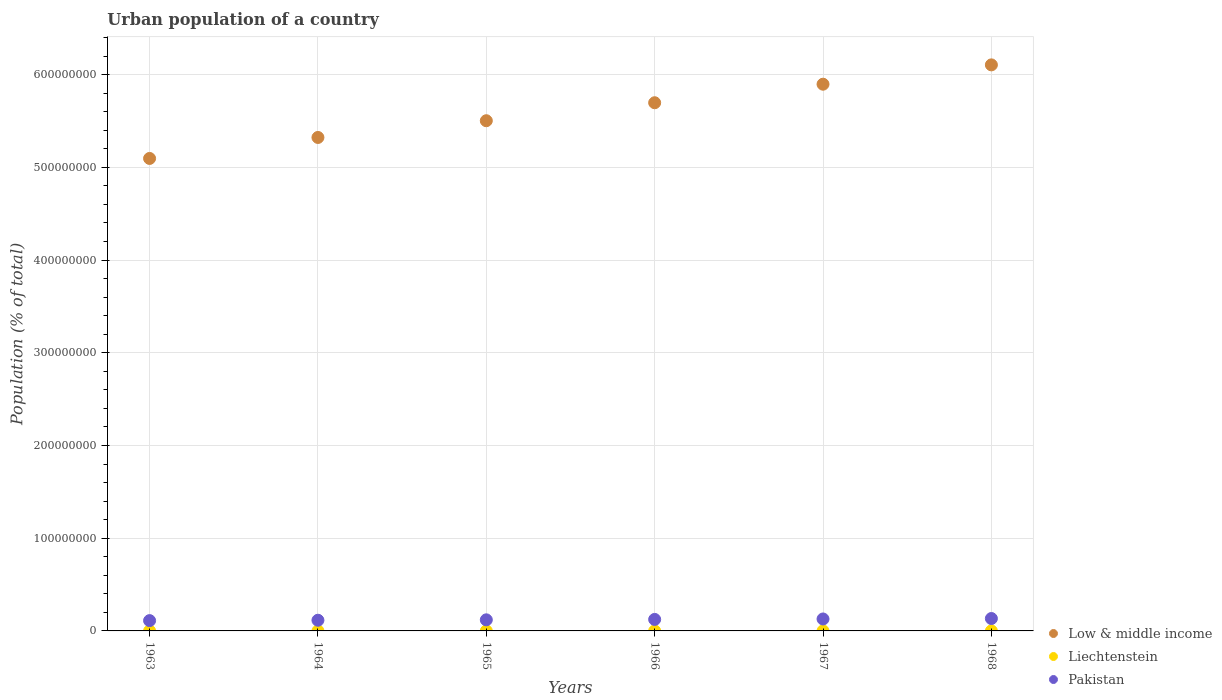How many different coloured dotlines are there?
Provide a succinct answer. 3. Is the number of dotlines equal to the number of legend labels?
Offer a very short reply. Yes. What is the urban population in Low & middle income in 1966?
Make the answer very short. 5.70e+08. Across all years, what is the maximum urban population in Low & middle income?
Offer a very short reply. 6.10e+08. Across all years, what is the minimum urban population in Low & middle income?
Keep it short and to the point. 5.10e+08. In which year was the urban population in Liechtenstein maximum?
Your answer should be very brief. 1968. What is the total urban population in Liechtenstein in the graph?
Offer a terse response. 2.20e+04. What is the difference between the urban population in Pakistan in 1965 and that in 1966?
Ensure brevity in your answer.  -4.51e+05. What is the difference between the urban population in Pakistan in 1968 and the urban population in Low & middle income in 1964?
Give a very brief answer. -5.19e+08. What is the average urban population in Pakistan per year?
Your answer should be compact. 1.22e+07. In the year 1968, what is the difference between the urban population in Liechtenstein and urban population in Pakistan?
Provide a succinct answer. -1.34e+07. What is the ratio of the urban population in Pakistan in 1967 to that in 1968?
Your answer should be very brief. 0.96. Is the urban population in Low & middle income in 1963 less than that in 1965?
Keep it short and to the point. Yes. What is the difference between the highest and the lowest urban population in Pakistan?
Your answer should be very brief. 2.26e+06. In how many years, is the urban population in Liechtenstein greater than the average urban population in Liechtenstein taken over all years?
Keep it short and to the point. 3. Is the sum of the urban population in Low & middle income in 1963 and 1966 greater than the maximum urban population in Pakistan across all years?
Offer a terse response. Yes. Is it the case that in every year, the sum of the urban population in Pakistan and urban population in Liechtenstein  is greater than the urban population in Low & middle income?
Give a very brief answer. No. Is the urban population in Liechtenstein strictly greater than the urban population in Low & middle income over the years?
Your answer should be very brief. No. Is the urban population in Liechtenstein strictly less than the urban population in Low & middle income over the years?
Make the answer very short. Yes. How many dotlines are there?
Make the answer very short. 3. How many years are there in the graph?
Your answer should be very brief. 6. Does the graph contain grids?
Make the answer very short. Yes. What is the title of the graph?
Make the answer very short. Urban population of a country. What is the label or title of the Y-axis?
Give a very brief answer. Population (% of total). What is the Population (% of total) of Low & middle income in 1963?
Ensure brevity in your answer.  5.10e+08. What is the Population (% of total) of Liechtenstein in 1963?
Offer a very short reply. 3525. What is the Population (% of total) in Pakistan in 1963?
Your answer should be compact. 1.11e+07. What is the Population (% of total) of Low & middle income in 1964?
Make the answer very short. 5.32e+08. What is the Population (% of total) of Liechtenstein in 1964?
Your answer should be compact. 3576. What is the Population (% of total) of Pakistan in 1964?
Your response must be concise. 1.15e+07. What is the Population (% of total) in Low & middle income in 1965?
Provide a short and direct response. 5.50e+08. What is the Population (% of total) of Liechtenstein in 1965?
Provide a succinct answer. 3631. What is the Population (% of total) in Pakistan in 1965?
Provide a short and direct response. 1.20e+07. What is the Population (% of total) in Low & middle income in 1966?
Give a very brief answer. 5.70e+08. What is the Population (% of total) in Liechtenstein in 1966?
Your response must be concise. 3690. What is the Population (% of total) in Pakistan in 1966?
Offer a terse response. 1.24e+07. What is the Population (% of total) of Low & middle income in 1967?
Offer a terse response. 5.90e+08. What is the Population (% of total) in Liechtenstein in 1967?
Your response must be concise. 3753. What is the Population (% of total) of Pakistan in 1967?
Provide a succinct answer. 1.29e+07. What is the Population (% of total) in Low & middle income in 1968?
Offer a very short reply. 6.10e+08. What is the Population (% of total) in Liechtenstein in 1968?
Your response must be concise. 3815. What is the Population (% of total) in Pakistan in 1968?
Offer a very short reply. 1.34e+07. Across all years, what is the maximum Population (% of total) of Low & middle income?
Keep it short and to the point. 6.10e+08. Across all years, what is the maximum Population (% of total) in Liechtenstein?
Offer a terse response. 3815. Across all years, what is the maximum Population (% of total) in Pakistan?
Give a very brief answer. 1.34e+07. Across all years, what is the minimum Population (% of total) of Low & middle income?
Provide a succinct answer. 5.10e+08. Across all years, what is the minimum Population (% of total) of Liechtenstein?
Keep it short and to the point. 3525. Across all years, what is the minimum Population (% of total) in Pakistan?
Make the answer very short. 1.11e+07. What is the total Population (% of total) in Low & middle income in the graph?
Your answer should be compact. 3.36e+09. What is the total Population (% of total) of Liechtenstein in the graph?
Ensure brevity in your answer.  2.20e+04. What is the total Population (% of total) of Pakistan in the graph?
Your answer should be very brief. 7.32e+07. What is the difference between the Population (% of total) in Low & middle income in 1963 and that in 1964?
Your answer should be very brief. -2.26e+07. What is the difference between the Population (% of total) of Liechtenstein in 1963 and that in 1964?
Provide a succinct answer. -51. What is the difference between the Population (% of total) in Pakistan in 1963 and that in 1964?
Give a very brief answer. -4.12e+05. What is the difference between the Population (% of total) in Low & middle income in 1963 and that in 1965?
Provide a short and direct response. -4.07e+07. What is the difference between the Population (% of total) in Liechtenstein in 1963 and that in 1965?
Make the answer very short. -106. What is the difference between the Population (% of total) in Pakistan in 1963 and that in 1965?
Provide a short and direct response. -8.42e+05. What is the difference between the Population (% of total) of Low & middle income in 1963 and that in 1966?
Provide a short and direct response. -6.01e+07. What is the difference between the Population (% of total) in Liechtenstein in 1963 and that in 1966?
Your response must be concise. -165. What is the difference between the Population (% of total) in Pakistan in 1963 and that in 1966?
Your response must be concise. -1.29e+06. What is the difference between the Population (% of total) of Low & middle income in 1963 and that in 1967?
Give a very brief answer. -8.01e+07. What is the difference between the Population (% of total) in Liechtenstein in 1963 and that in 1967?
Offer a very short reply. -228. What is the difference between the Population (% of total) of Pakistan in 1963 and that in 1967?
Ensure brevity in your answer.  -1.76e+06. What is the difference between the Population (% of total) of Low & middle income in 1963 and that in 1968?
Offer a terse response. -1.01e+08. What is the difference between the Population (% of total) in Liechtenstein in 1963 and that in 1968?
Your answer should be compact. -290. What is the difference between the Population (% of total) in Pakistan in 1963 and that in 1968?
Your response must be concise. -2.26e+06. What is the difference between the Population (% of total) in Low & middle income in 1964 and that in 1965?
Provide a succinct answer. -1.80e+07. What is the difference between the Population (% of total) of Liechtenstein in 1964 and that in 1965?
Your response must be concise. -55. What is the difference between the Population (% of total) in Pakistan in 1964 and that in 1965?
Offer a terse response. -4.30e+05. What is the difference between the Population (% of total) of Low & middle income in 1964 and that in 1966?
Provide a short and direct response. -3.74e+07. What is the difference between the Population (% of total) in Liechtenstein in 1964 and that in 1966?
Provide a short and direct response. -114. What is the difference between the Population (% of total) of Pakistan in 1964 and that in 1966?
Your answer should be compact. -8.82e+05. What is the difference between the Population (% of total) in Low & middle income in 1964 and that in 1967?
Your answer should be compact. -5.74e+07. What is the difference between the Population (% of total) of Liechtenstein in 1964 and that in 1967?
Your response must be concise. -177. What is the difference between the Population (% of total) in Pakistan in 1964 and that in 1967?
Provide a short and direct response. -1.35e+06. What is the difference between the Population (% of total) in Low & middle income in 1964 and that in 1968?
Your answer should be compact. -7.83e+07. What is the difference between the Population (% of total) in Liechtenstein in 1964 and that in 1968?
Make the answer very short. -239. What is the difference between the Population (% of total) in Pakistan in 1964 and that in 1968?
Provide a succinct answer. -1.85e+06. What is the difference between the Population (% of total) in Low & middle income in 1965 and that in 1966?
Keep it short and to the point. -1.94e+07. What is the difference between the Population (% of total) of Liechtenstein in 1965 and that in 1966?
Offer a terse response. -59. What is the difference between the Population (% of total) in Pakistan in 1965 and that in 1966?
Offer a very short reply. -4.51e+05. What is the difference between the Population (% of total) of Low & middle income in 1965 and that in 1967?
Your response must be concise. -3.94e+07. What is the difference between the Population (% of total) in Liechtenstein in 1965 and that in 1967?
Your response must be concise. -122. What is the difference between the Population (% of total) of Pakistan in 1965 and that in 1967?
Provide a succinct answer. -9.23e+05. What is the difference between the Population (% of total) of Low & middle income in 1965 and that in 1968?
Provide a succinct answer. -6.02e+07. What is the difference between the Population (% of total) in Liechtenstein in 1965 and that in 1968?
Provide a succinct answer. -184. What is the difference between the Population (% of total) of Pakistan in 1965 and that in 1968?
Your answer should be very brief. -1.42e+06. What is the difference between the Population (% of total) of Low & middle income in 1966 and that in 1967?
Make the answer very short. -2.00e+07. What is the difference between the Population (% of total) in Liechtenstein in 1966 and that in 1967?
Offer a very short reply. -63. What is the difference between the Population (% of total) of Pakistan in 1966 and that in 1967?
Offer a terse response. -4.72e+05. What is the difference between the Population (% of total) of Low & middle income in 1966 and that in 1968?
Provide a succinct answer. -4.08e+07. What is the difference between the Population (% of total) in Liechtenstein in 1966 and that in 1968?
Give a very brief answer. -125. What is the difference between the Population (% of total) in Pakistan in 1966 and that in 1968?
Ensure brevity in your answer.  -9.64e+05. What is the difference between the Population (% of total) in Low & middle income in 1967 and that in 1968?
Your answer should be very brief. -2.08e+07. What is the difference between the Population (% of total) in Liechtenstein in 1967 and that in 1968?
Your answer should be very brief. -62. What is the difference between the Population (% of total) in Pakistan in 1967 and that in 1968?
Give a very brief answer. -4.92e+05. What is the difference between the Population (% of total) in Low & middle income in 1963 and the Population (% of total) in Liechtenstein in 1964?
Provide a short and direct response. 5.10e+08. What is the difference between the Population (% of total) of Low & middle income in 1963 and the Population (% of total) of Pakistan in 1964?
Provide a short and direct response. 4.98e+08. What is the difference between the Population (% of total) of Liechtenstein in 1963 and the Population (% of total) of Pakistan in 1964?
Offer a terse response. -1.15e+07. What is the difference between the Population (% of total) in Low & middle income in 1963 and the Population (% of total) in Liechtenstein in 1965?
Provide a short and direct response. 5.10e+08. What is the difference between the Population (% of total) in Low & middle income in 1963 and the Population (% of total) in Pakistan in 1965?
Offer a terse response. 4.98e+08. What is the difference between the Population (% of total) of Liechtenstein in 1963 and the Population (% of total) of Pakistan in 1965?
Ensure brevity in your answer.  -1.20e+07. What is the difference between the Population (% of total) in Low & middle income in 1963 and the Population (% of total) in Liechtenstein in 1966?
Provide a succinct answer. 5.10e+08. What is the difference between the Population (% of total) of Low & middle income in 1963 and the Population (% of total) of Pakistan in 1966?
Offer a very short reply. 4.97e+08. What is the difference between the Population (% of total) of Liechtenstein in 1963 and the Population (% of total) of Pakistan in 1966?
Provide a succinct answer. -1.24e+07. What is the difference between the Population (% of total) of Low & middle income in 1963 and the Population (% of total) of Liechtenstein in 1967?
Offer a very short reply. 5.10e+08. What is the difference between the Population (% of total) of Low & middle income in 1963 and the Population (% of total) of Pakistan in 1967?
Offer a very short reply. 4.97e+08. What is the difference between the Population (% of total) in Liechtenstein in 1963 and the Population (% of total) in Pakistan in 1967?
Provide a succinct answer. -1.29e+07. What is the difference between the Population (% of total) in Low & middle income in 1963 and the Population (% of total) in Liechtenstein in 1968?
Offer a very short reply. 5.10e+08. What is the difference between the Population (% of total) of Low & middle income in 1963 and the Population (% of total) of Pakistan in 1968?
Make the answer very short. 4.96e+08. What is the difference between the Population (% of total) of Liechtenstein in 1963 and the Population (% of total) of Pakistan in 1968?
Your answer should be compact. -1.34e+07. What is the difference between the Population (% of total) of Low & middle income in 1964 and the Population (% of total) of Liechtenstein in 1965?
Ensure brevity in your answer.  5.32e+08. What is the difference between the Population (% of total) of Low & middle income in 1964 and the Population (% of total) of Pakistan in 1965?
Give a very brief answer. 5.20e+08. What is the difference between the Population (% of total) in Liechtenstein in 1964 and the Population (% of total) in Pakistan in 1965?
Provide a short and direct response. -1.20e+07. What is the difference between the Population (% of total) of Low & middle income in 1964 and the Population (% of total) of Liechtenstein in 1966?
Keep it short and to the point. 5.32e+08. What is the difference between the Population (% of total) in Low & middle income in 1964 and the Population (% of total) in Pakistan in 1966?
Make the answer very short. 5.20e+08. What is the difference between the Population (% of total) of Liechtenstein in 1964 and the Population (% of total) of Pakistan in 1966?
Ensure brevity in your answer.  -1.24e+07. What is the difference between the Population (% of total) of Low & middle income in 1964 and the Population (% of total) of Liechtenstein in 1967?
Offer a very short reply. 5.32e+08. What is the difference between the Population (% of total) of Low & middle income in 1964 and the Population (% of total) of Pakistan in 1967?
Make the answer very short. 5.19e+08. What is the difference between the Population (% of total) of Liechtenstein in 1964 and the Population (% of total) of Pakistan in 1967?
Give a very brief answer. -1.29e+07. What is the difference between the Population (% of total) in Low & middle income in 1964 and the Population (% of total) in Liechtenstein in 1968?
Provide a short and direct response. 5.32e+08. What is the difference between the Population (% of total) in Low & middle income in 1964 and the Population (% of total) in Pakistan in 1968?
Your answer should be very brief. 5.19e+08. What is the difference between the Population (% of total) of Liechtenstein in 1964 and the Population (% of total) of Pakistan in 1968?
Offer a terse response. -1.34e+07. What is the difference between the Population (% of total) of Low & middle income in 1965 and the Population (% of total) of Liechtenstein in 1966?
Provide a short and direct response. 5.50e+08. What is the difference between the Population (% of total) in Low & middle income in 1965 and the Population (% of total) in Pakistan in 1966?
Offer a very short reply. 5.38e+08. What is the difference between the Population (% of total) of Liechtenstein in 1965 and the Population (% of total) of Pakistan in 1966?
Your answer should be compact. -1.24e+07. What is the difference between the Population (% of total) of Low & middle income in 1965 and the Population (% of total) of Liechtenstein in 1967?
Provide a short and direct response. 5.50e+08. What is the difference between the Population (% of total) of Low & middle income in 1965 and the Population (% of total) of Pakistan in 1967?
Your answer should be compact. 5.37e+08. What is the difference between the Population (% of total) of Liechtenstein in 1965 and the Population (% of total) of Pakistan in 1967?
Provide a succinct answer. -1.29e+07. What is the difference between the Population (% of total) in Low & middle income in 1965 and the Population (% of total) in Liechtenstein in 1968?
Provide a short and direct response. 5.50e+08. What is the difference between the Population (% of total) of Low & middle income in 1965 and the Population (% of total) of Pakistan in 1968?
Provide a short and direct response. 5.37e+08. What is the difference between the Population (% of total) in Liechtenstein in 1965 and the Population (% of total) in Pakistan in 1968?
Your answer should be compact. -1.34e+07. What is the difference between the Population (% of total) of Low & middle income in 1966 and the Population (% of total) of Liechtenstein in 1967?
Your answer should be very brief. 5.70e+08. What is the difference between the Population (% of total) in Low & middle income in 1966 and the Population (% of total) in Pakistan in 1967?
Give a very brief answer. 5.57e+08. What is the difference between the Population (% of total) in Liechtenstein in 1966 and the Population (% of total) in Pakistan in 1967?
Provide a short and direct response. -1.29e+07. What is the difference between the Population (% of total) in Low & middle income in 1966 and the Population (% of total) in Liechtenstein in 1968?
Offer a very short reply. 5.70e+08. What is the difference between the Population (% of total) of Low & middle income in 1966 and the Population (% of total) of Pakistan in 1968?
Your answer should be compact. 5.56e+08. What is the difference between the Population (% of total) in Liechtenstein in 1966 and the Population (% of total) in Pakistan in 1968?
Provide a succinct answer. -1.34e+07. What is the difference between the Population (% of total) of Low & middle income in 1967 and the Population (% of total) of Liechtenstein in 1968?
Ensure brevity in your answer.  5.90e+08. What is the difference between the Population (% of total) in Low & middle income in 1967 and the Population (% of total) in Pakistan in 1968?
Keep it short and to the point. 5.76e+08. What is the difference between the Population (% of total) of Liechtenstein in 1967 and the Population (% of total) of Pakistan in 1968?
Give a very brief answer. -1.34e+07. What is the average Population (% of total) of Low & middle income per year?
Give a very brief answer. 5.60e+08. What is the average Population (% of total) in Liechtenstein per year?
Offer a very short reply. 3665. What is the average Population (% of total) of Pakistan per year?
Your answer should be compact. 1.22e+07. In the year 1963, what is the difference between the Population (% of total) in Low & middle income and Population (% of total) in Liechtenstein?
Make the answer very short. 5.10e+08. In the year 1963, what is the difference between the Population (% of total) in Low & middle income and Population (% of total) in Pakistan?
Ensure brevity in your answer.  4.98e+08. In the year 1963, what is the difference between the Population (% of total) in Liechtenstein and Population (% of total) in Pakistan?
Offer a very short reply. -1.11e+07. In the year 1964, what is the difference between the Population (% of total) of Low & middle income and Population (% of total) of Liechtenstein?
Make the answer very short. 5.32e+08. In the year 1964, what is the difference between the Population (% of total) of Low & middle income and Population (% of total) of Pakistan?
Your answer should be compact. 5.21e+08. In the year 1964, what is the difference between the Population (% of total) in Liechtenstein and Population (% of total) in Pakistan?
Offer a very short reply. -1.15e+07. In the year 1965, what is the difference between the Population (% of total) of Low & middle income and Population (% of total) of Liechtenstein?
Ensure brevity in your answer.  5.50e+08. In the year 1965, what is the difference between the Population (% of total) of Low & middle income and Population (% of total) of Pakistan?
Keep it short and to the point. 5.38e+08. In the year 1965, what is the difference between the Population (% of total) in Liechtenstein and Population (% of total) in Pakistan?
Make the answer very short. -1.20e+07. In the year 1966, what is the difference between the Population (% of total) of Low & middle income and Population (% of total) of Liechtenstein?
Your response must be concise. 5.70e+08. In the year 1966, what is the difference between the Population (% of total) of Low & middle income and Population (% of total) of Pakistan?
Offer a very short reply. 5.57e+08. In the year 1966, what is the difference between the Population (% of total) of Liechtenstein and Population (% of total) of Pakistan?
Keep it short and to the point. -1.24e+07. In the year 1967, what is the difference between the Population (% of total) in Low & middle income and Population (% of total) in Liechtenstein?
Give a very brief answer. 5.90e+08. In the year 1967, what is the difference between the Population (% of total) in Low & middle income and Population (% of total) in Pakistan?
Offer a terse response. 5.77e+08. In the year 1967, what is the difference between the Population (% of total) in Liechtenstein and Population (% of total) in Pakistan?
Offer a terse response. -1.29e+07. In the year 1968, what is the difference between the Population (% of total) of Low & middle income and Population (% of total) of Liechtenstein?
Offer a terse response. 6.10e+08. In the year 1968, what is the difference between the Population (% of total) of Low & middle income and Population (% of total) of Pakistan?
Keep it short and to the point. 5.97e+08. In the year 1968, what is the difference between the Population (% of total) in Liechtenstein and Population (% of total) in Pakistan?
Ensure brevity in your answer.  -1.34e+07. What is the ratio of the Population (% of total) in Low & middle income in 1963 to that in 1964?
Offer a terse response. 0.96. What is the ratio of the Population (% of total) of Liechtenstein in 1963 to that in 1964?
Give a very brief answer. 0.99. What is the ratio of the Population (% of total) of Low & middle income in 1963 to that in 1965?
Make the answer very short. 0.93. What is the ratio of the Population (% of total) of Liechtenstein in 1963 to that in 1965?
Ensure brevity in your answer.  0.97. What is the ratio of the Population (% of total) of Pakistan in 1963 to that in 1965?
Provide a short and direct response. 0.93. What is the ratio of the Population (% of total) in Low & middle income in 1963 to that in 1966?
Keep it short and to the point. 0.89. What is the ratio of the Population (% of total) of Liechtenstein in 1963 to that in 1966?
Your answer should be compact. 0.96. What is the ratio of the Population (% of total) in Pakistan in 1963 to that in 1966?
Make the answer very short. 0.9. What is the ratio of the Population (% of total) of Low & middle income in 1963 to that in 1967?
Your answer should be compact. 0.86. What is the ratio of the Population (% of total) in Liechtenstein in 1963 to that in 1967?
Give a very brief answer. 0.94. What is the ratio of the Population (% of total) of Pakistan in 1963 to that in 1967?
Keep it short and to the point. 0.86. What is the ratio of the Population (% of total) in Low & middle income in 1963 to that in 1968?
Offer a terse response. 0.83. What is the ratio of the Population (% of total) of Liechtenstein in 1963 to that in 1968?
Offer a terse response. 0.92. What is the ratio of the Population (% of total) in Pakistan in 1963 to that in 1968?
Your answer should be very brief. 0.83. What is the ratio of the Population (% of total) of Low & middle income in 1964 to that in 1965?
Provide a short and direct response. 0.97. What is the ratio of the Population (% of total) in Liechtenstein in 1964 to that in 1965?
Provide a succinct answer. 0.98. What is the ratio of the Population (% of total) in Low & middle income in 1964 to that in 1966?
Ensure brevity in your answer.  0.93. What is the ratio of the Population (% of total) of Liechtenstein in 1964 to that in 1966?
Give a very brief answer. 0.97. What is the ratio of the Population (% of total) in Pakistan in 1964 to that in 1966?
Offer a terse response. 0.93. What is the ratio of the Population (% of total) in Low & middle income in 1964 to that in 1967?
Your answer should be very brief. 0.9. What is the ratio of the Population (% of total) in Liechtenstein in 1964 to that in 1967?
Keep it short and to the point. 0.95. What is the ratio of the Population (% of total) in Pakistan in 1964 to that in 1967?
Ensure brevity in your answer.  0.89. What is the ratio of the Population (% of total) of Low & middle income in 1964 to that in 1968?
Provide a short and direct response. 0.87. What is the ratio of the Population (% of total) of Liechtenstein in 1964 to that in 1968?
Your answer should be very brief. 0.94. What is the ratio of the Population (% of total) in Pakistan in 1964 to that in 1968?
Your answer should be compact. 0.86. What is the ratio of the Population (% of total) in Low & middle income in 1965 to that in 1966?
Keep it short and to the point. 0.97. What is the ratio of the Population (% of total) in Pakistan in 1965 to that in 1966?
Offer a very short reply. 0.96. What is the ratio of the Population (% of total) in Low & middle income in 1965 to that in 1967?
Offer a terse response. 0.93. What is the ratio of the Population (% of total) in Liechtenstein in 1965 to that in 1967?
Offer a very short reply. 0.97. What is the ratio of the Population (% of total) of Pakistan in 1965 to that in 1967?
Your answer should be compact. 0.93. What is the ratio of the Population (% of total) of Low & middle income in 1965 to that in 1968?
Your response must be concise. 0.9. What is the ratio of the Population (% of total) in Liechtenstein in 1965 to that in 1968?
Provide a succinct answer. 0.95. What is the ratio of the Population (% of total) of Pakistan in 1965 to that in 1968?
Ensure brevity in your answer.  0.89. What is the ratio of the Population (% of total) in Low & middle income in 1966 to that in 1967?
Offer a very short reply. 0.97. What is the ratio of the Population (% of total) in Liechtenstein in 1966 to that in 1967?
Give a very brief answer. 0.98. What is the ratio of the Population (% of total) in Pakistan in 1966 to that in 1967?
Provide a short and direct response. 0.96. What is the ratio of the Population (% of total) of Low & middle income in 1966 to that in 1968?
Offer a terse response. 0.93. What is the ratio of the Population (% of total) of Liechtenstein in 1966 to that in 1968?
Offer a very short reply. 0.97. What is the ratio of the Population (% of total) of Pakistan in 1966 to that in 1968?
Offer a terse response. 0.93. What is the ratio of the Population (% of total) of Low & middle income in 1967 to that in 1968?
Ensure brevity in your answer.  0.97. What is the ratio of the Population (% of total) in Liechtenstein in 1967 to that in 1968?
Your response must be concise. 0.98. What is the ratio of the Population (% of total) in Pakistan in 1967 to that in 1968?
Your answer should be compact. 0.96. What is the difference between the highest and the second highest Population (% of total) in Low & middle income?
Offer a terse response. 2.08e+07. What is the difference between the highest and the second highest Population (% of total) in Liechtenstein?
Give a very brief answer. 62. What is the difference between the highest and the second highest Population (% of total) in Pakistan?
Give a very brief answer. 4.92e+05. What is the difference between the highest and the lowest Population (% of total) of Low & middle income?
Provide a succinct answer. 1.01e+08. What is the difference between the highest and the lowest Population (% of total) of Liechtenstein?
Offer a very short reply. 290. What is the difference between the highest and the lowest Population (% of total) in Pakistan?
Your answer should be compact. 2.26e+06. 